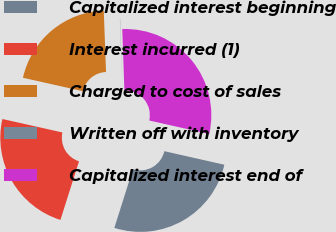<chart> <loc_0><loc_0><loc_500><loc_500><pie_chart><fcel>Capitalized interest beginning<fcel>Interest incurred (1)<fcel>Charged to cost of sales<fcel>Written off with inventory<fcel>Capitalized interest end of<nl><fcel>26.35%<fcel>23.63%<fcel>20.9%<fcel>0.04%<fcel>29.08%<nl></chart> 